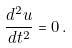<formula> <loc_0><loc_0><loc_500><loc_500>\frac { d ^ { 2 } { u } } { d t ^ { 2 } } = 0 \, .</formula> 